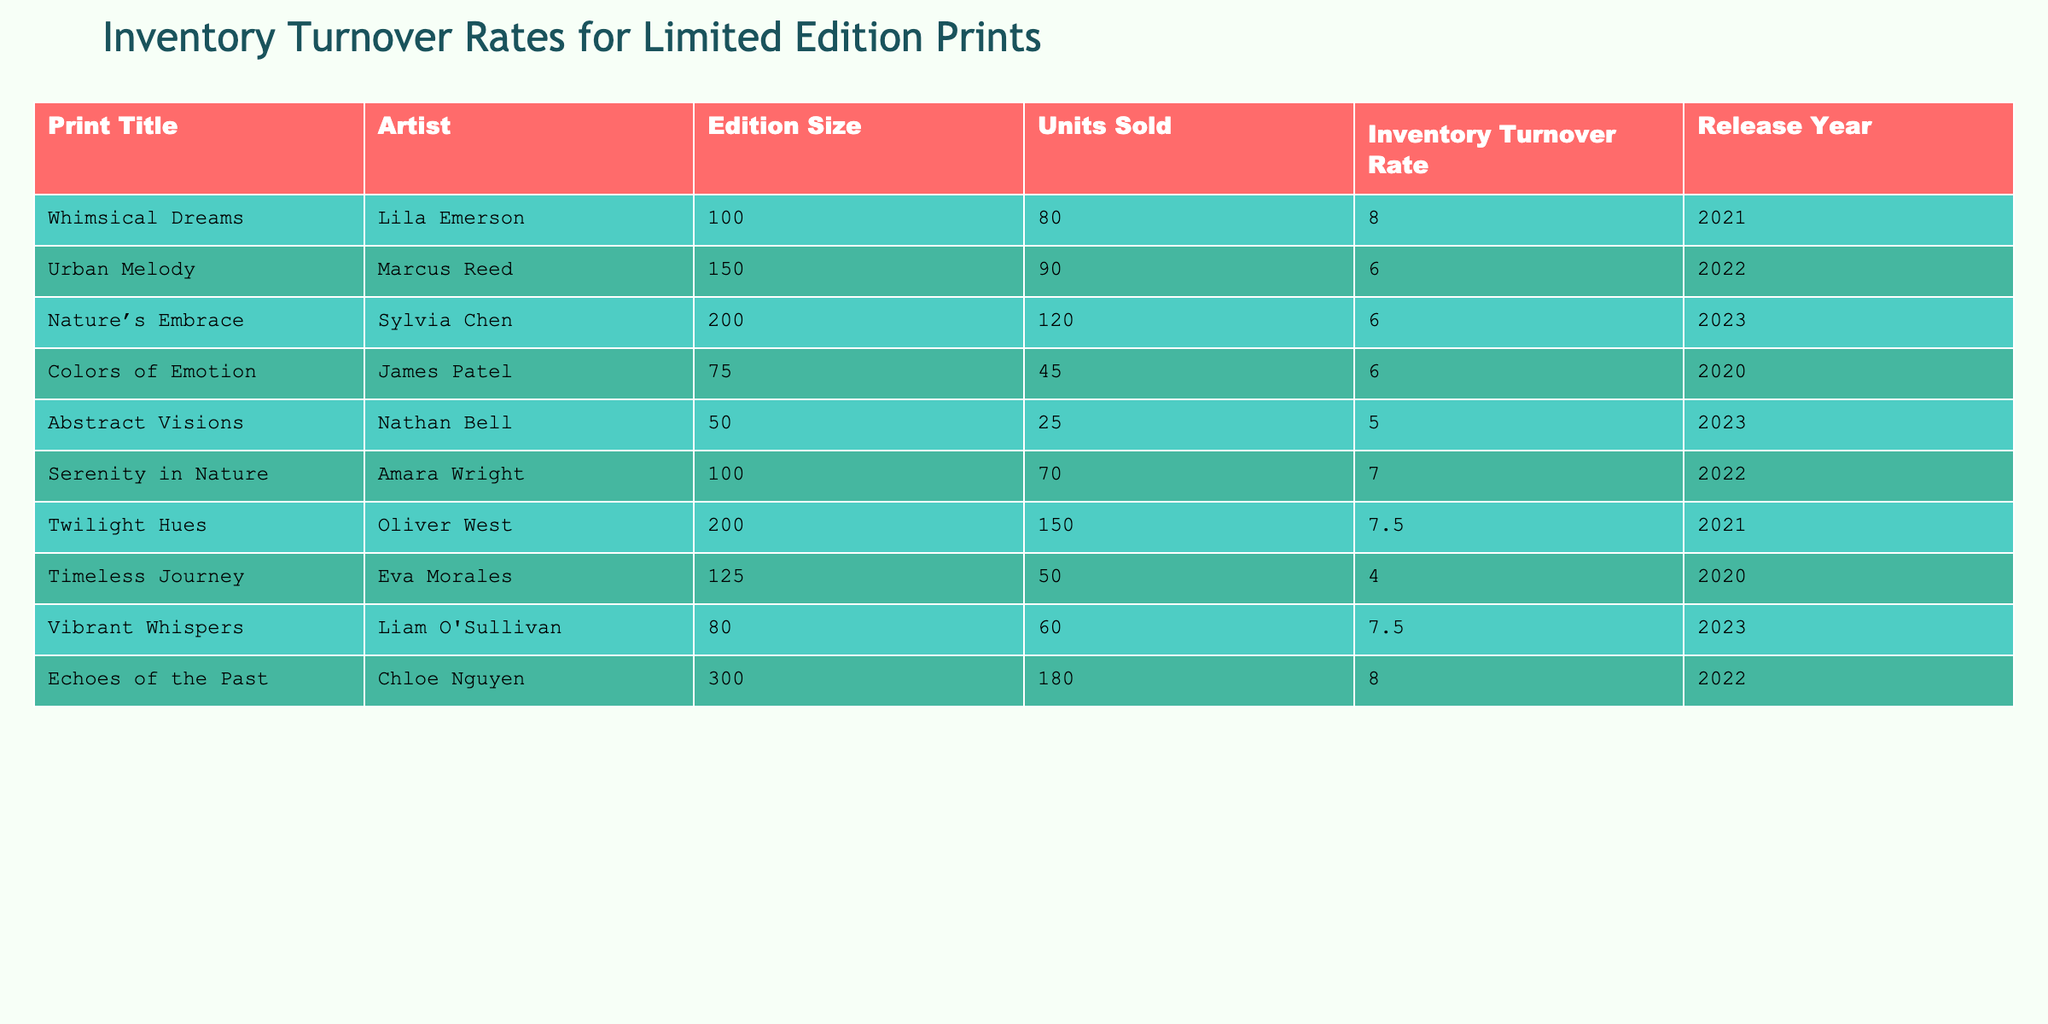What is the inventory turnover rate for "Whimsical Dreams"? The table lists the "Inventory Turnover Rate" value next to the title "Whimsical Dreams," which is 8.0.
Answer: 8.0 Who is the artist of "Echoes of the Past"? The table shows that "Echoes of the Past" is associated with the artist Chloe Nguyen.
Answer: Chloe Nguyen What is the total number of units sold for prints released in 2022? The prints released in 2022 are "Urban Melody" (90 units) and "Serenity in Nature" (70 units). Adding these gives 90 + 70 = 160 units sold in total for 2022.
Answer: 160 Is the edition size for "Timeless Journey" greater than 100? The edition size for "Timeless Journey" is 125, which is indeed greater than 100.
Answer: Yes Which print had the highest inventory turnover rate? By examining the "Inventory Turnover Rate" column, "Whimsical Dreams" and "Echoes of the Past" both have the highest rate at 8.0.
Answer: "Whimsical Dreams" and "Echoes of the Past" What is the average inventory turnover rate for the prints released in 2023? For 2023, the inventory turnover rates are 6.0 (for "Nature's Embrace"), 5.0 (for "Abstract Visions"), and 7.5 (for "Vibrant Whispers"). Adding these gives 6.0 + 5.0 + 7.5 = 18.5; dividing by 3 totals 18.5/3 = 6.17.
Answer: 6.17 Which print had the lowest units sold? The print with the lowest units sold is "Abstract Visions" with 25 units sold.
Answer: "Abstract Visions" Are there any prints with an inventory turnover rate above 7.0? Yes, both "Whimsical Dreams" (8.0) and "Echoes of the Past" (8.0) exceed an inventory turnover rate of 7.0.
Answer: Yes Which artist has the most prints listed in the table? Each artist has only one print listed in the table. So, there is no artist with more than one print.
Answer: No artist has more prints listed 